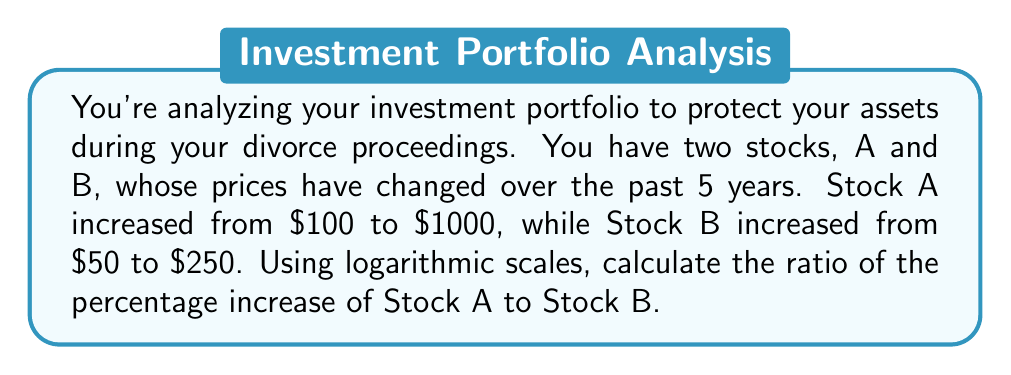Show me your answer to this math problem. 1. Calculate the percentage increase for each stock:
   Stock A: $(1000 - 100) / 100 * 100\% = 900\%$
   Stock B: $(250 - 50) / 50 * 100\% = 400\%$

2. To use logarithmic scales, we need to calculate the logarithm of the ratio of final price to initial price for each stock:
   Stock A: $\log(1000/100) = \log(10) = 1$
   Stock B: $\log(250/50) = \log(5) = 0.699$

3. The ratio of the logarithmic increases is:
   $\frac{\log(1000/100)}{\log(250/50)} = \frac{1}{0.699} \approx 1.43$

4. This ratio represents the relative rate of growth between the two stocks on a logarithmic scale. To convert it to a ratio of percentage increases, we need to exponentiate:

   $10^{1.43} \approx 26.91$

5. Therefore, the ratio of the percentage increase of Stock A to Stock B is approximately 26.91 to 1.
Answer: 26.91:1 